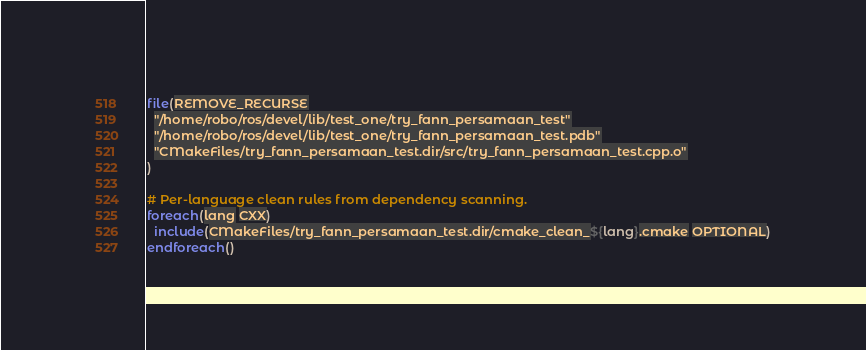<code> <loc_0><loc_0><loc_500><loc_500><_CMake_>file(REMOVE_RECURSE
  "/home/robo/ros/devel/lib/test_one/try_fann_persamaan_test"
  "/home/robo/ros/devel/lib/test_one/try_fann_persamaan_test.pdb"
  "CMakeFiles/try_fann_persamaan_test.dir/src/try_fann_persamaan_test.cpp.o"
)

# Per-language clean rules from dependency scanning.
foreach(lang CXX)
  include(CMakeFiles/try_fann_persamaan_test.dir/cmake_clean_${lang}.cmake OPTIONAL)
endforeach()
</code> 